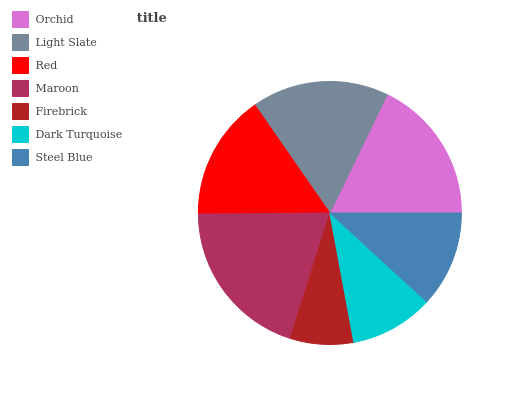Is Firebrick the minimum?
Answer yes or no. Yes. Is Maroon the maximum?
Answer yes or no. Yes. Is Light Slate the minimum?
Answer yes or no. No. Is Light Slate the maximum?
Answer yes or no. No. Is Orchid greater than Light Slate?
Answer yes or no. Yes. Is Light Slate less than Orchid?
Answer yes or no. Yes. Is Light Slate greater than Orchid?
Answer yes or no. No. Is Orchid less than Light Slate?
Answer yes or no. No. Is Red the high median?
Answer yes or no. Yes. Is Red the low median?
Answer yes or no. Yes. Is Maroon the high median?
Answer yes or no. No. Is Steel Blue the low median?
Answer yes or no. No. 